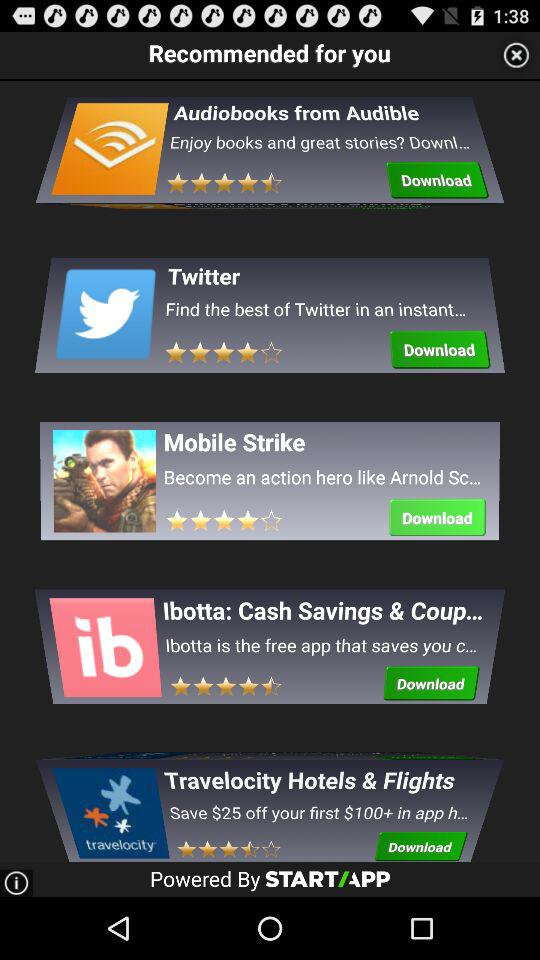How many apps are recommended for you?
Answer the question using a single word or phrase. 5 